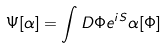Convert formula to latex. <formula><loc_0><loc_0><loc_500><loc_500>\Psi [ \alpha ] = \int D \Phi e ^ { i S } \alpha [ \Phi ]</formula> 